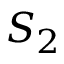<formula> <loc_0><loc_0><loc_500><loc_500>S _ { 2 }</formula> 